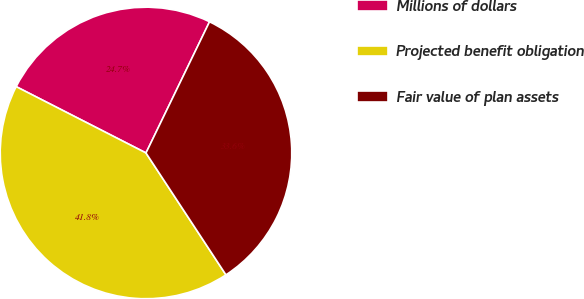<chart> <loc_0><loc_0><loc_500><loc_500><pie_chart><fcel>Millions of dollars<fcel>Projected benefit obligation<fcel>Fair value of plan assets<nl><fcel>24.66%<fcel>41.76%<fcel>33.58%<nl></chart> 